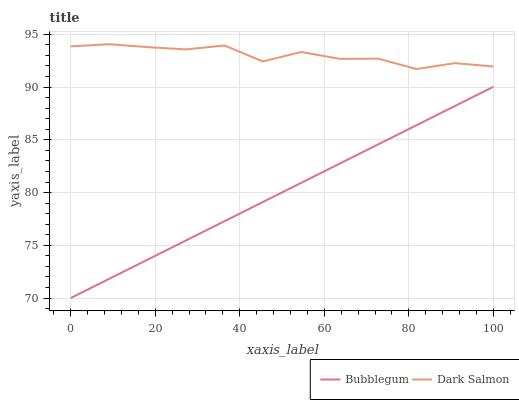Does Bubblegum have the minimum area under the curve?
Answer yes or no. Yes. Does Dark Salmon have the maximum area under the curve?
Answer yes or no. Yes. Does Bubblegum have the maximum area under the curve?
Answer yes or no. No. Is Bubblegum the smoothest?
Answer yes or no. Yes. Is Dark Salmon the roughest?
Answer yes or no. Yes. Is Bubblegum the roughest?
Answer yes or no. No. Does Bubblegum have the lowest value?
Answer yes or no. Yes. Does Dark Salmon have the highest value?
Answer yes or no. Yes. Does Bubblegum have the highest value?
Answer yes or no. No. Is Bubblegum less than Dark Salmon?
Answer yes or no. Yes. Is Dark Salmon greater than Bubblegum?
Answer yes or no. Yes. Does Bubblegum intersect Dark Salmon?
Answer yes or no. No. 